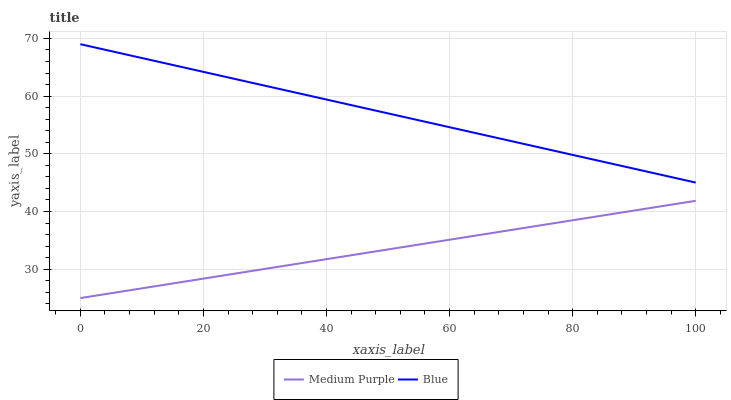Does Medium Purple have the minimum area under the curve?
Answer yes or no. Yes. Does Blue have the maximum area under the curve?
Answer yes or no. Yes. Does Blue have the minimum area under the curve?
Answer yes or no. No. Is Medium Purple the smoothest?
Answer yes or no. Yes. Is Blue the roughest?
Answer yes or no. Yes. Is Blue the smoothest?
Answer yes or no. No. Does Medium Purple have the lowest value?
Answer yes or no. Yes. Does Blue have the lowest value?
Answer yes or no. No. Does Blue have the highest value?
Answer yes or no. Yes. Is Medium Purple less than Blue?
Answer yes or no. Yes. Is Blue greater than Medium Purple?
Answer yes or no. Yes. Does Medium Purple intersect Blue?
Answer yes or no. No. 